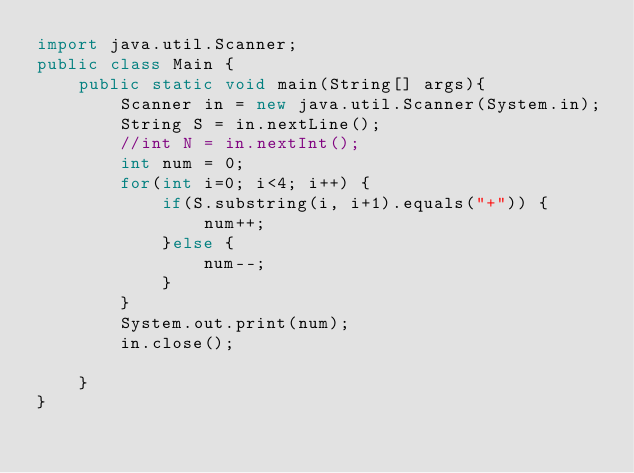<code> <loc_0><loc_0><loc_500><loc_500><_Java_>import java.util.Scanner;
public class Main {
	public static void main(String[] args){
		Scanner in = new java.util.Scanner(System.in);
		String S = in.nextLine();
		//int N = in.nextInt();
		int num = 0;
		for(int i=0; i<4; i++) {
			if(S.substring(i, i+1).equals("+")) {
				num++;
			}else {
				num--;
			}
		}
		System.out.print(num);
		in.close();
		
	}
}</code> 